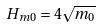<formula> <loc_0><loc_0><loc_500><loc_500>H _ { m 0 } = 4 \sqrt { m _ { 0 } }</formula> 